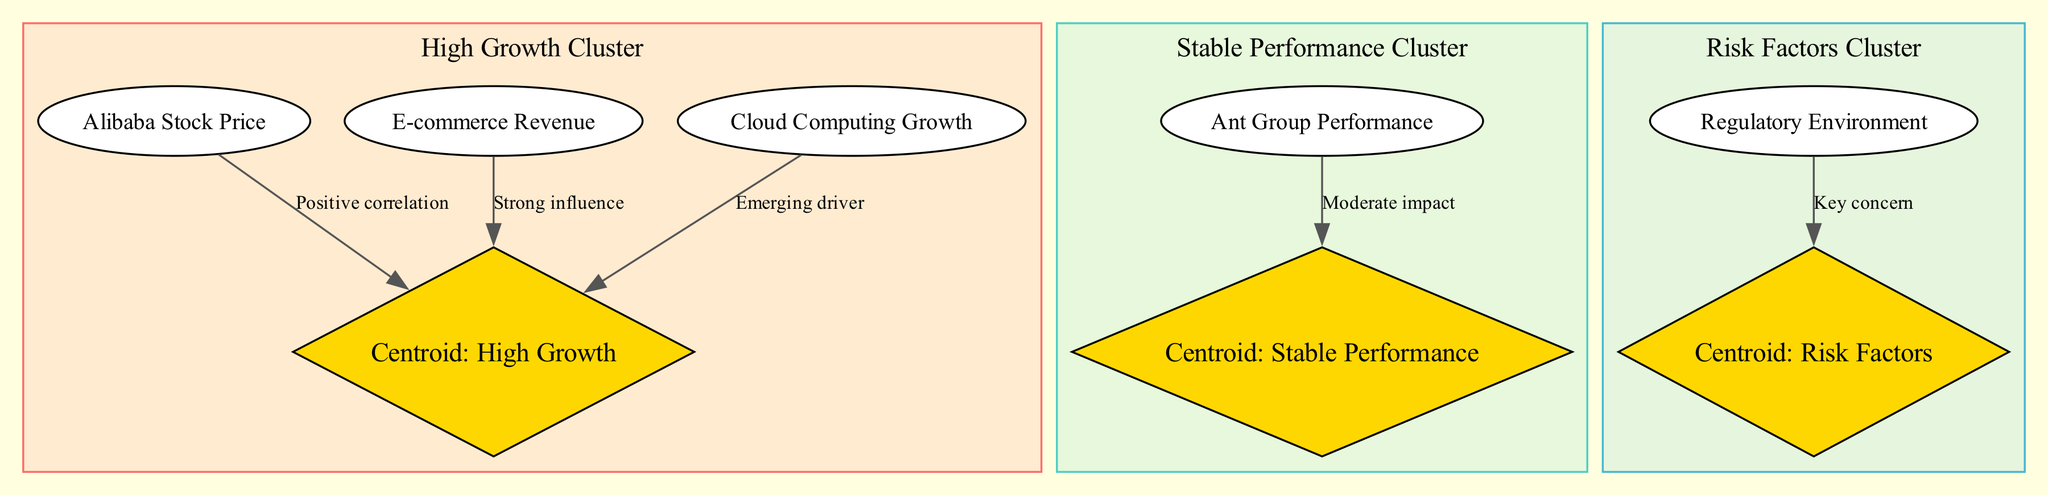What is the label of the first node? The first node in the diagram is labeled "Alibaba Stock Price."
Answer: Alibaba Stock Price How many clusters are there in the diagram? The diagram shows three clusters labeled "High Growth Cluster," "Stable Performance Cluster," and "Risk Factors Cluster."
Answer: 3 What type of correlation exists between Alibaba Stock Price and the High Growth centroid? The edge between "Alibaba Stock Price" and "Centroid: High Growth" indicates a "Positive correlation."
Answer: Positive correlation Which nodes are part of the Stable Performance Cluster? The Stable Performance Cluster consists of the nodes "Ant Group Performance" and "Centroid: Stable Performance."
Answer: Ant Group Performance, Centroid: Stable Performance What is the impact of the Regulatory Environment on the Risk Factors centroid? The edge illustrates that the "Regulatory Environment" has a "Key concern" connection to the "Centroid: Risk Factors."
Answer: Key concern What are the nodes included in the High Growth Cluster? The High Growth Cluster incorporates "Alibaba Stock Price," "E-commerce Revenue," "Cloud Computing Growth," and "Centroid: High Growth."
Answer: Alibaba Stock Price, E-commerce Revenue, Cloud Computing Growth, Centroid: High Growth Which centroid has a moderate impact noted in the edges? The "Centroid: Stable Performance" receives a "Moderate impact" from "Ant Group Performance."
Answer: Centroid: Stable Performance Which node has the strongest influence on the High Growth centroid? The diagram shows that "E-commerce Revenue" has a "Strong influence" on the "Centroid: High Growth."
Answer: E-commerce Revenue 